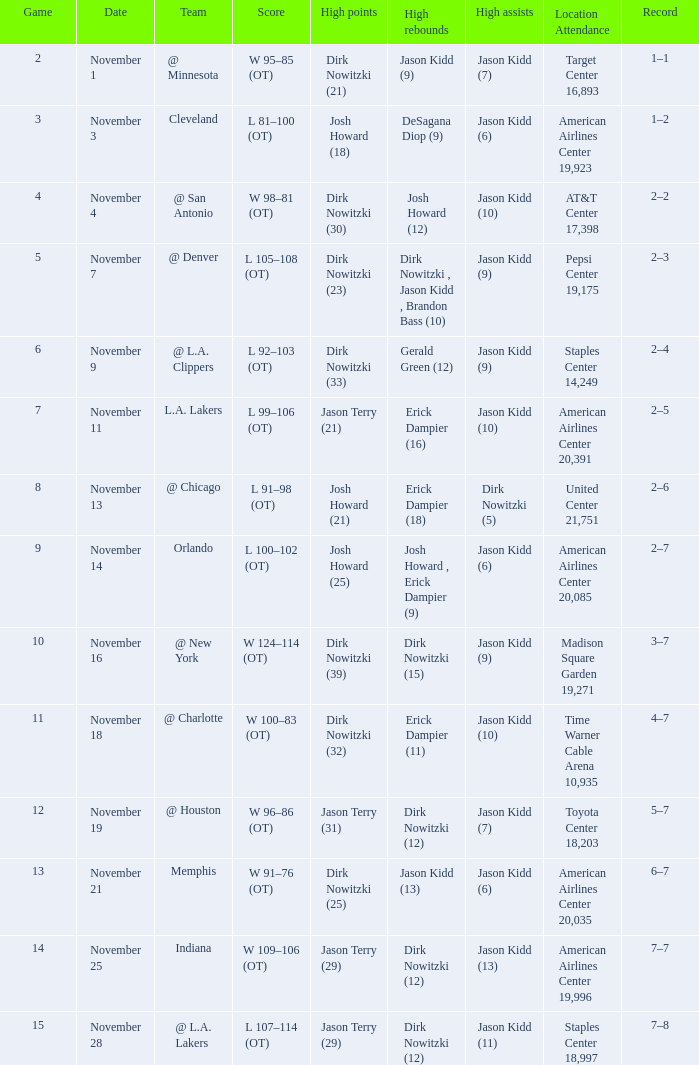What was the record on November 1? 1–1. 